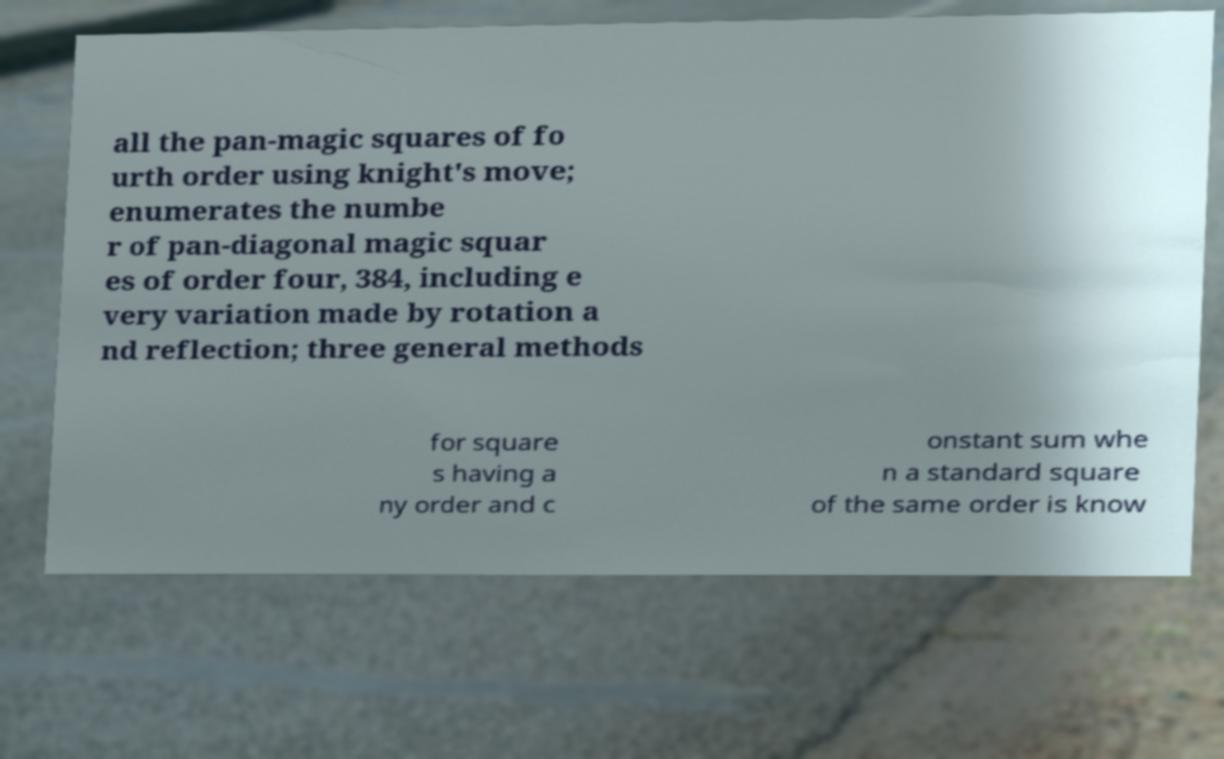For documentation purposes, I need the text within this image transcribed. Could you provide that? all the pan-magic squares of fo urth order using knight's move; enumerates the numbe r of pan-diagonal magic squar es of order four, 384, including e very variation made by rotation a nd reflection; three general methods for square s having a ny order and c onstant sum whe n a standard square of the same order is know 